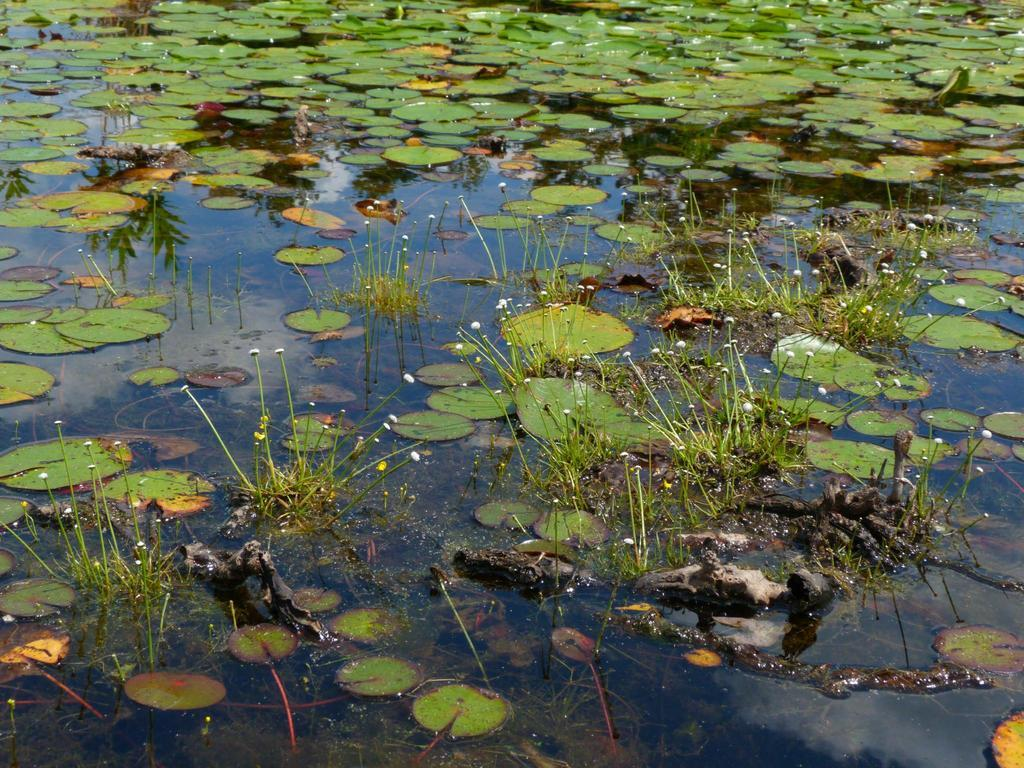What type of plants can be seen in the image? There are flowers in the image. What color are the flowers? The flowers are white. What else is present in the image besides flowers? There are leaves in the image. What color are the leaves? The leaves are green. Where are the leaves located in the image? The leaves are on the water. What type of juice can be seen in the image? There is no juice present in the image; it features flowers and leaves on the water. Is there any smoke visible in the image? There is no smoke present in the image. 